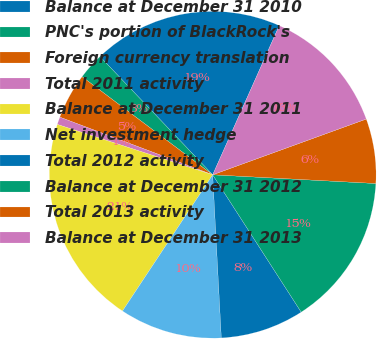Convert chart. <chart><loc_0><loc_0><loc_500><loc_500><pie_chart><fcel>Balance at December 31 2010<fcel>PNC's portion of BlackRock's<fcel>Foreign currency translation<fcel>Total 2011 activity<fcel>Balance at December 31 2011<fcel>Net investment hedge<fcel>Total 2012 activity<fcel>Balance at December 31 2012<fcel>Total 2013 activity<fcel>Balance at December 31 2013<nl><fcel>18.8%<fcel>2.63%<fcel>4.51%<fcel>0.75%<fcel>20.68%<fcel>10.15%<fcel>8.27%<fcel>15.04%<fcel>6.39%<fcel>12.78%<nl></chart> 